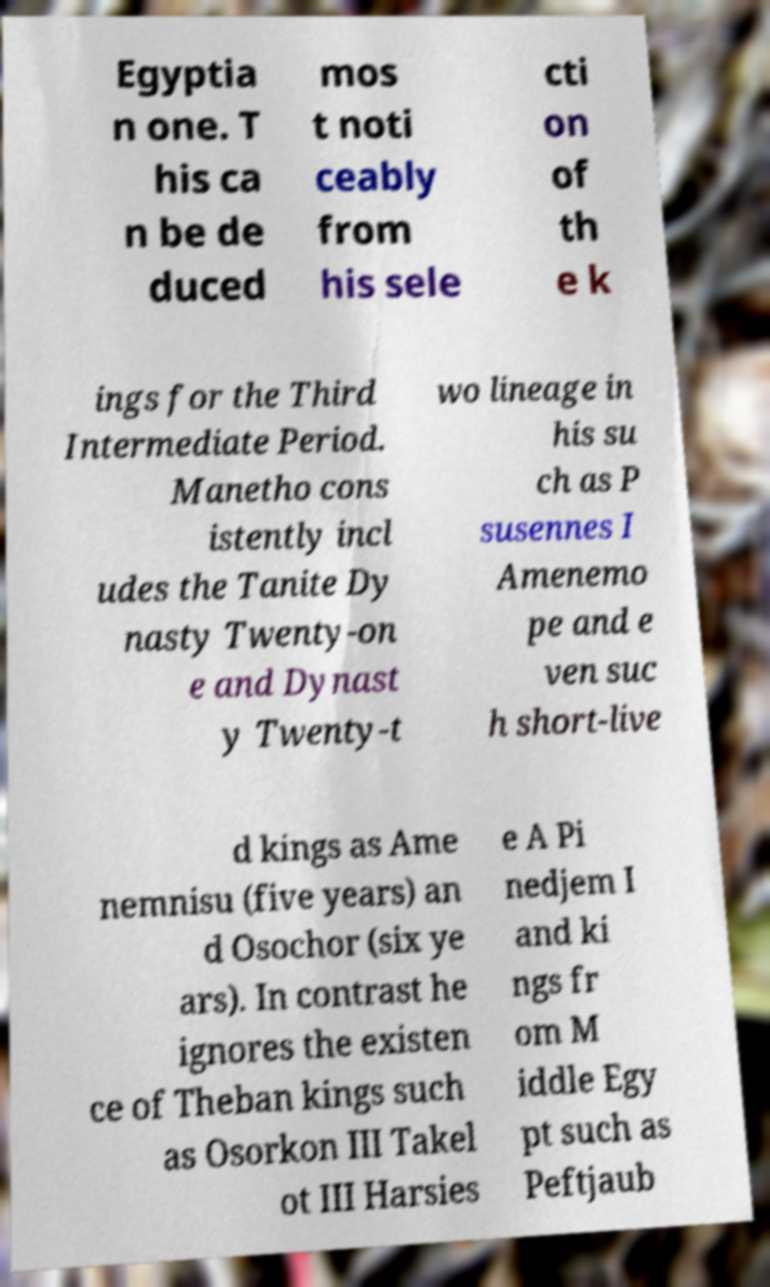Could you assist in decoding the text presented in this image and type it out clearly? Egyptia n one. T his ca n be de duced mos t noti ceably from his sele cti on of th e k ings for the Third Intermediate Period. Manetho cons istently incl udes the Tanite Dy nasty Twenty-on e and Dynast y Twenty-t wo lineage in his su ch as P susennes I Amenemo pe and e ven suc h short-live d kings as Ame nemnisu (five years) an d Osochor (six ye ars). In contrast he ignores the existen ce of Theban kings such as Osorkon III Takel ot III Harsies e A Pi nedjem I and ki ngs fr om M iddle Egy pt such as Peftjaub 